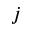<formula> <loc_0><loc_0><loc_500><loc_500>j</formula> 